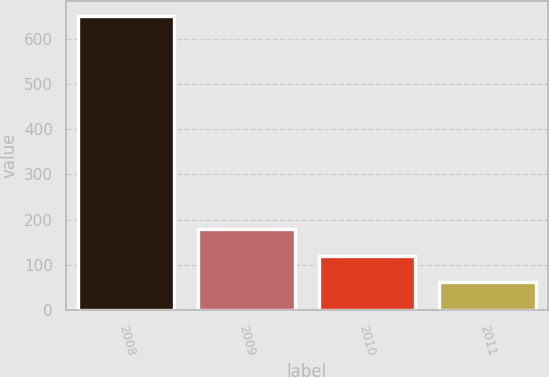Convert chart to OTSL. <chart><loc_0><loc_0><loc_500><loc_500><bar_chart><fcel>2008<fcel>2009<fcel>2010<fcel>2011<nl><fcel>650<fcel>178.8<fcel>119.9<fcel>61<nl></chart> 